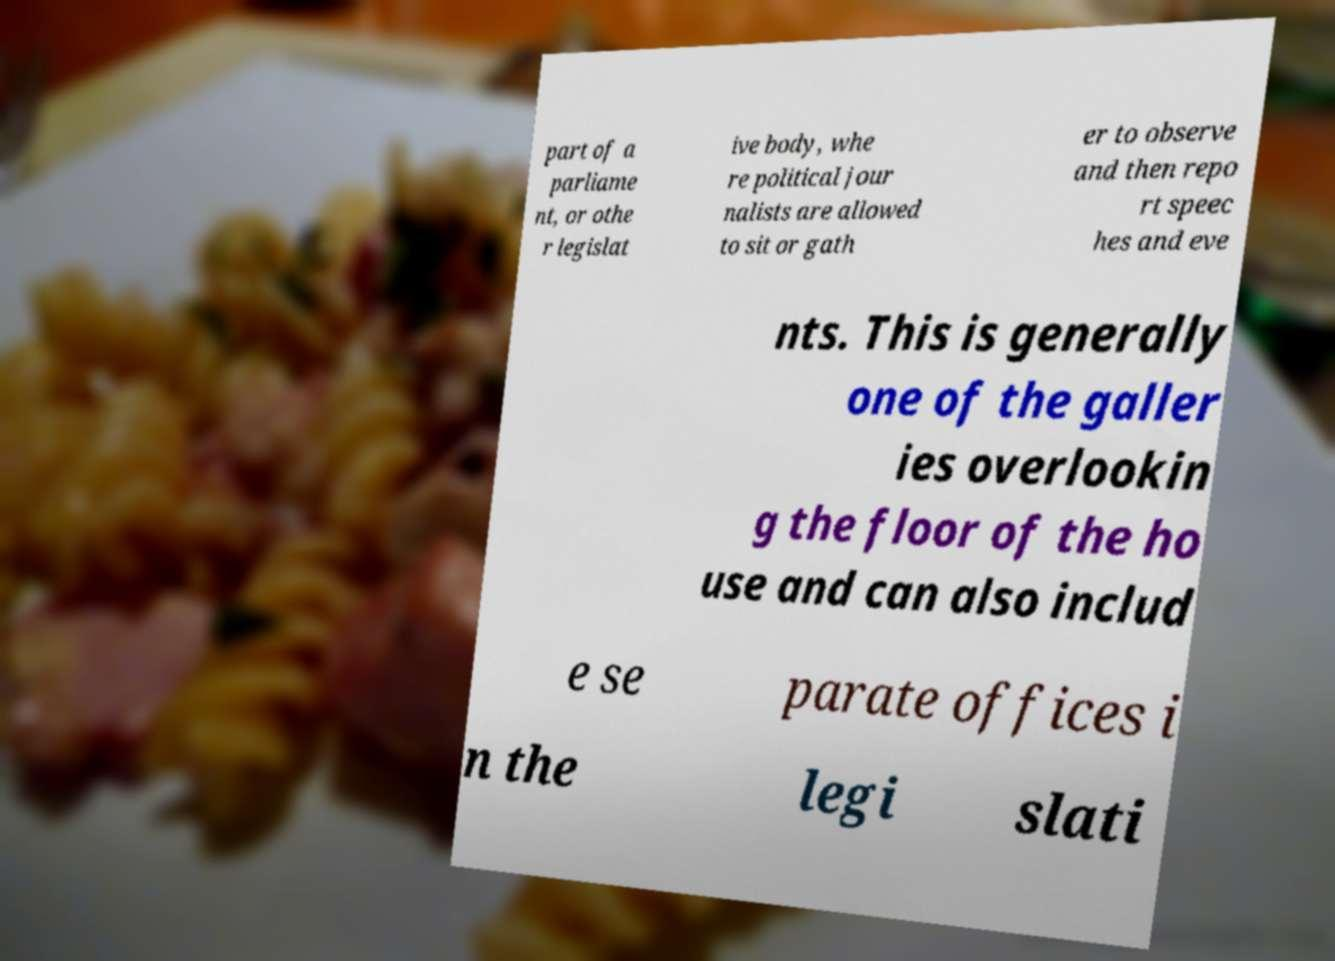For documentation purposes, I need the text within this image transcribed. Could you provide that? part of a parliame nt, or othe r legislat ive body, whe re political jour nalists are allowed to sit or gath er to observe and then repo rt speec hes and eve nts. This is generally one of the galler ies overlookin g the floor of the ho use and can also includ e se parate offices i n the legi slati 